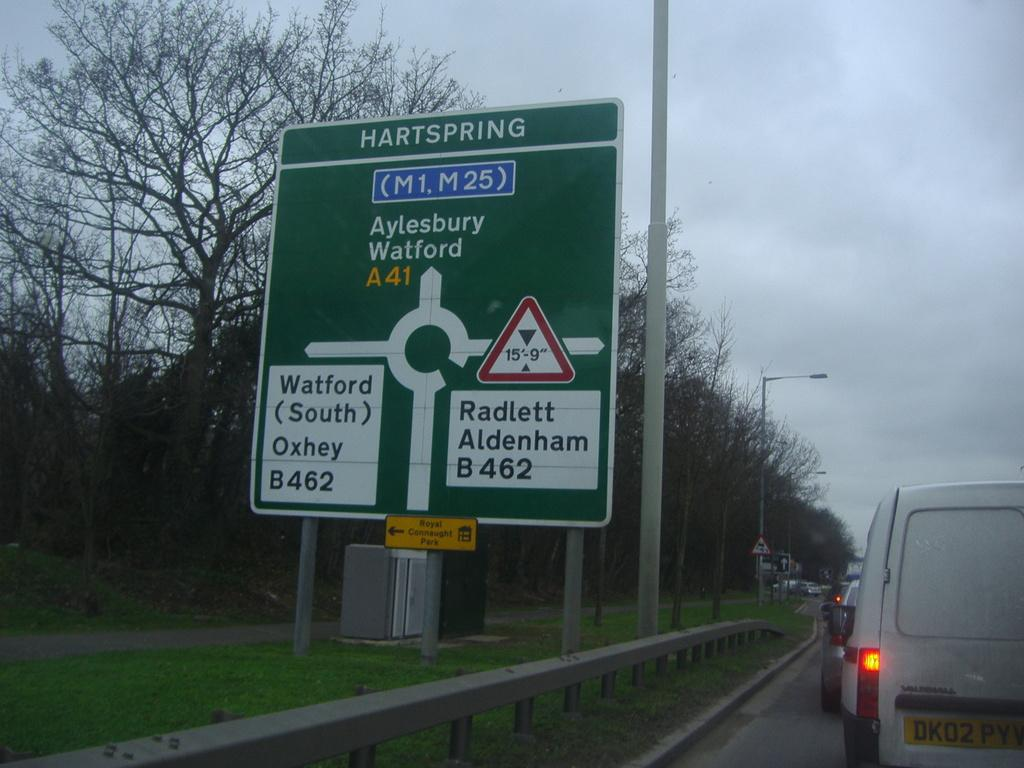<image>
Summarize the visual content of the image. The sign along the highway warns that if you turn right, the maximum clearance is 15' 9" high. 